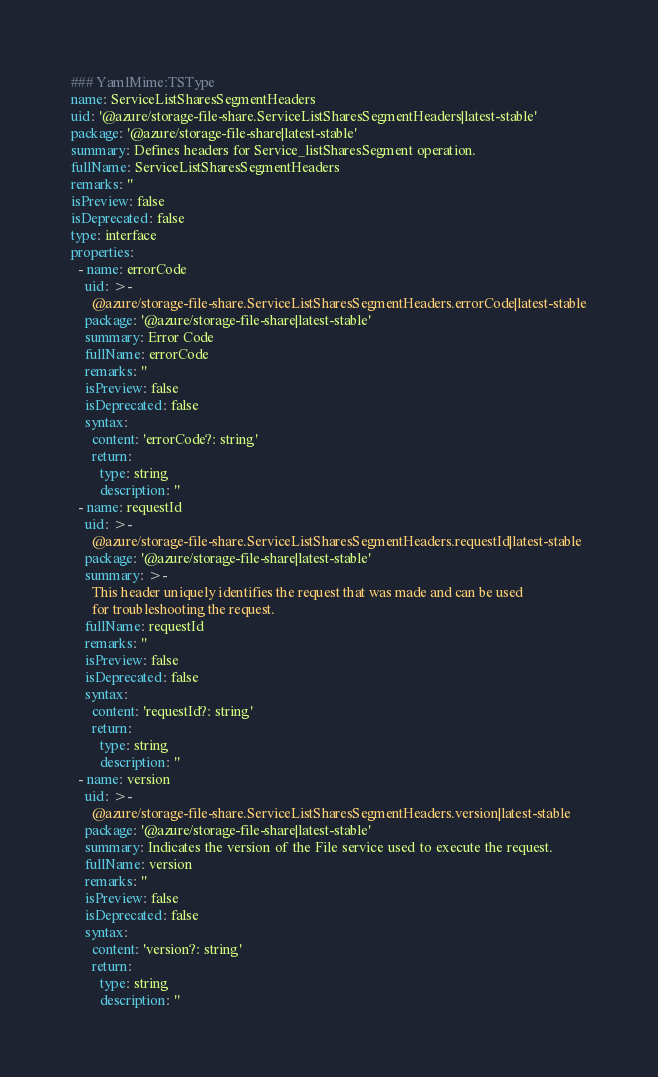<code> <loc_0><loc_0><loc_500><loc_500><_YAML_>### YamlMime:TSType
name: ServiceListSharesSegmentHeaders
uid: '@azure/storage-file-share.ServiceListSharesSegmentHeaders|latest-stable'
package: '@azure/storage-file-share|latest-stable'
summary: Defines headers for Service_listSharesSegment operation.
fullName: ServiceListSharesSegmentHeaders
remarks: ''
isPreview: false
isDeprecated: false
type: interface
properties:
  - name: errorCode
    uid: >-
      @azure/storage-file-share.ServiceListSharesSegmentHeaders.errorCode|latest-stable
    package: '@azure/storage-file-share|latest-stable'
    summary: Error Code
    fullName: errorCode
    remarks: ''
    isPreview: false
    isDeprecated: false
    syntax:
      content: 'errorCode?: string'
      return:
        type: string
        description: ''
  - name: requestId
    uid: >-
      @azure/storage-file-share.ServiceListSharesSegmentHeaders.requestId|latest-stable
    package: '@azure/storage-file-share|latest-stable'
    summary: >-
      This header uniquely identifies the request that was made and can be used
      for troubleshooting the request.
    fullName: requestId
    remarks: ''
    isPreview: false
    isDeprecated: false
    syntax:
      content: 'requestId?: string'
      return:
        type: string
        description: ''
  - name: version
    uid: >-
      @azure/storage-file-share.ServiceListSharesSegmentHeaders.version|latest-stable
    package: '@azure/storage-file-share|latest-stable'
    summary: Indicates the version of the File service used to execute the request.
    fullName: version
    remarks: ''
    isPreview: false
    isDeprecated: false
    syntax:
      content: 'version?: string'
      return:
        type: string
        description: ''
</code> 